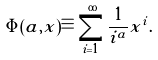Convert formula to latex. <formula><loc_0><loc_0><loc_500><loc_500>\Phi ( a , x ) \equiv \sum _ { i = 1 } ^ { \infty } \frac { 1 } { i ^ { a } } x ^ { i } .</formula> 